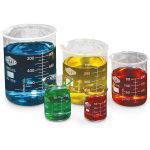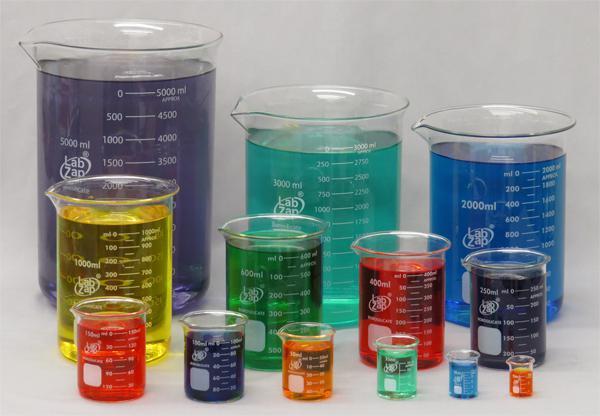The first image is the image on the left, the second image is the image on the right. Analyze the images presented: Is the assertion "One image features exactly five beakers of different liquid colors, in the same shape but different sizes." valid? Answer yes or no. Yes. 